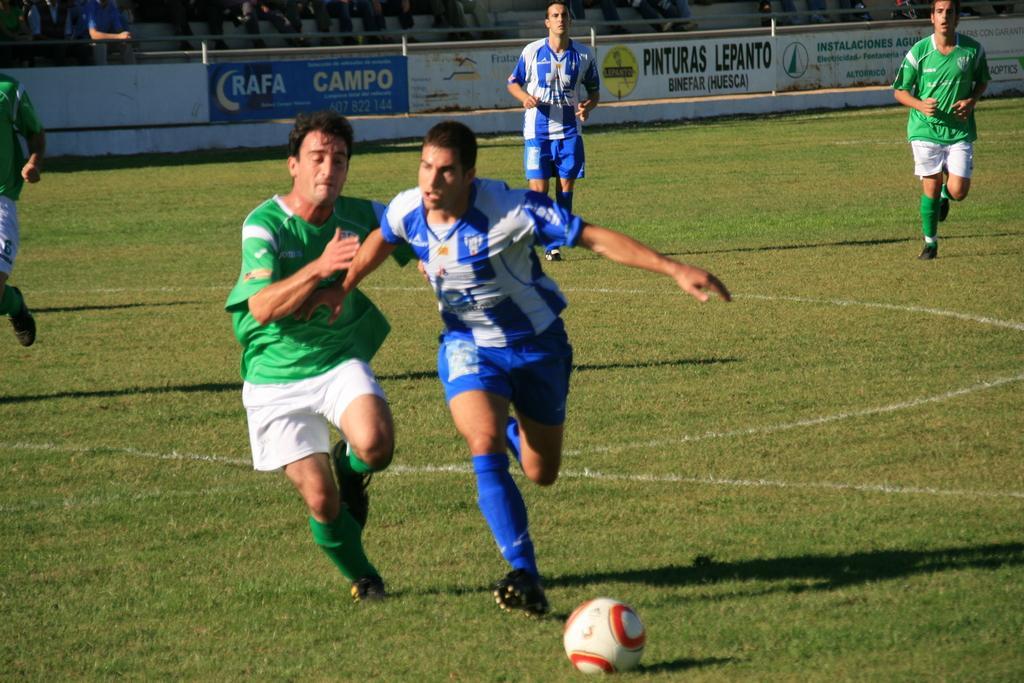Could you give a brief overview of what you see in this image? In this image we can see a group of people wearing dress are standing on the grass field. In the foreground we can see a ball. In the background, we can see group of audience and sign boards with some text. 